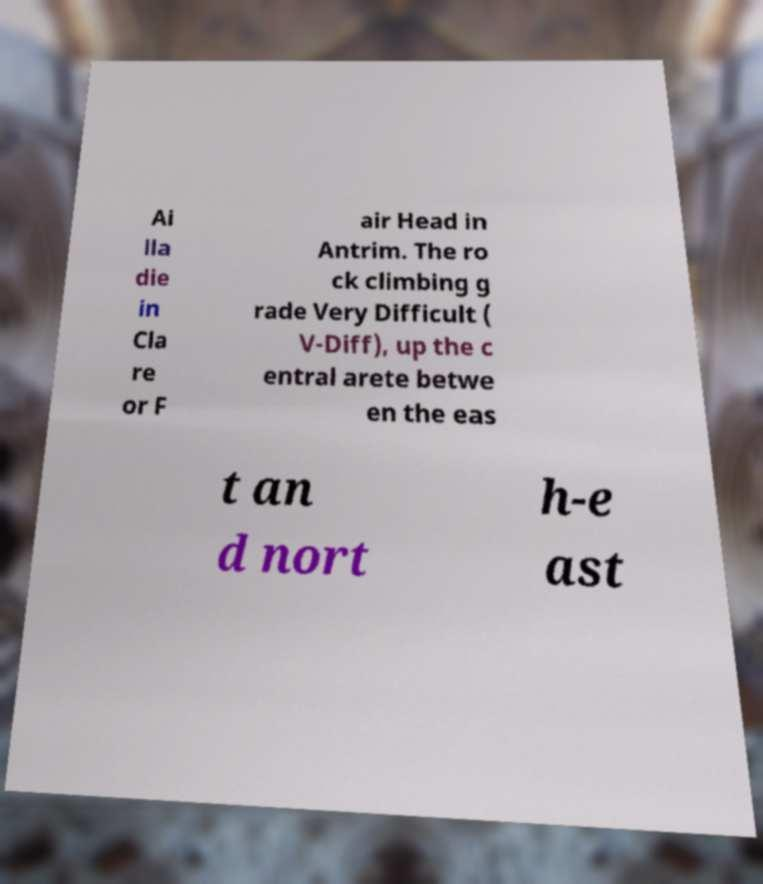Can you read and provide the text displayed in the image?This photo seems to have some interesting text. Can you extract and type it out for me? Ai lla die in Cla re or F air Head in Antrim. The ro ck climbing g rade Very Difficult ( V-Diff), up the c entral arete betwe en the eas t an d nort h-e ast 